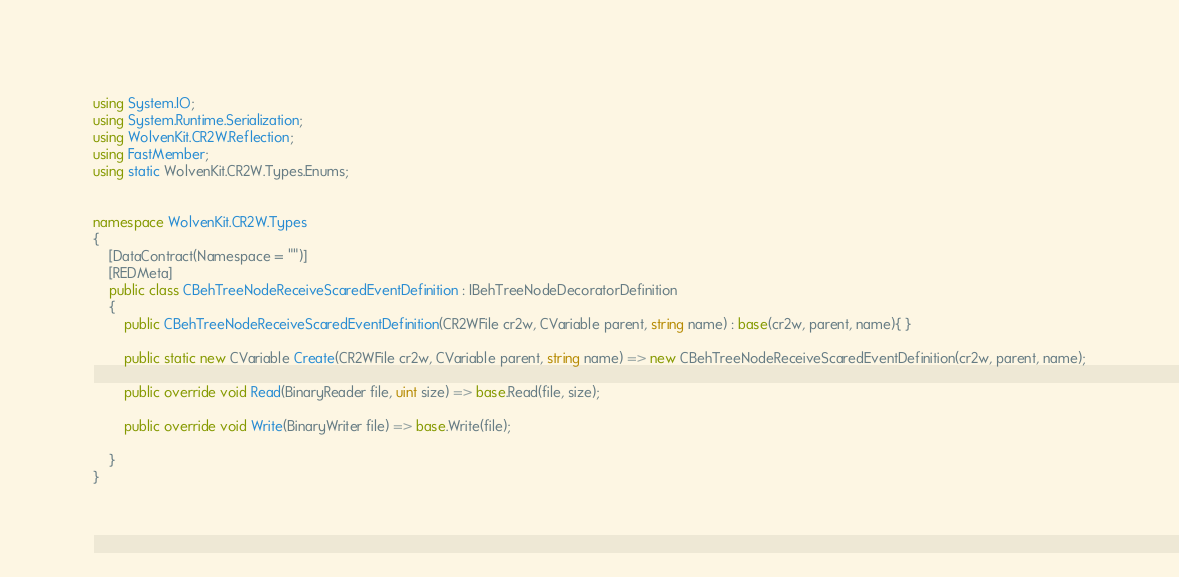Convert code to text. <code><loc_0><loc_0><loc_500><loc_500><_C#_>using System.IO;
using System.Runtime.Serialization;
using WolvenKit.CR2W.Reflection;
using FastMember;
using static WolvenKit.CR2W.Types.Enums;


namespace WolvenKit.CR2W.Types
{
	[DataContract(Namespace = "")]
	[REDMeta]
	public class CBehTreeNodeReceiveScaredEventDefinition : IBehTreeNodeDecoratorDefinition
	{
		public CBehTreeNodeReceiveScaredEventDefinition(CR2WFile cr2w, CVariable parent, string name) : base(cr2w, parent, name){ }

		public static new CVariable Create(CR2WFile cr2w, CVariable parent, string name) => new CBehTreeNodeReceiveScaredEventDefinition(cr2w, parent, name);

		public override void Read(BinaryReader file, uint size) => base.Read(file, size);

		public override void Write(BinaryWriter file) => base.Write(file);

	}
}</code> 